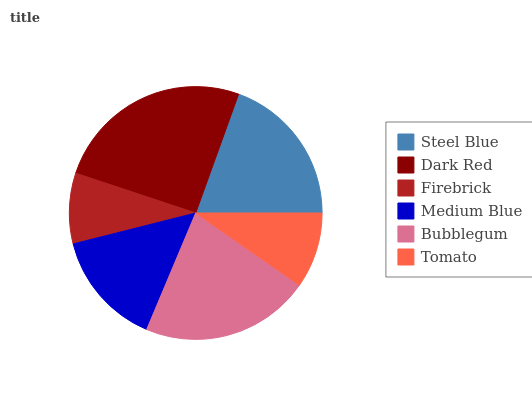Is Firebrick the minimum?
Answer yes or no. Yes. Is Dark Red the maximum?
Answer yes or no. Yes. Is Dark Red the minimum?
Answer yes or no. No. Is Firebrick the maximum?
Answer yes or no. No. Is Dark Red greater than Firebrick?
Answer yes or no. Yes. Is Firebrick less than Dark Red?
Answer yes or no. Yes. Is Firebrick greater than Dark Red?
Answer yes or no. No. Is Dark Red less than Firebrick?
Answer yes or no. No. Is Steel Blue the high median?
Answer yes or no. Yes. Is Medium Blue the low median?
Answer yes or no. Yes. Is Firebrick the high median?
Answer yes or no. No. Is Dark Red the low median?
Answer yes or no. No. 